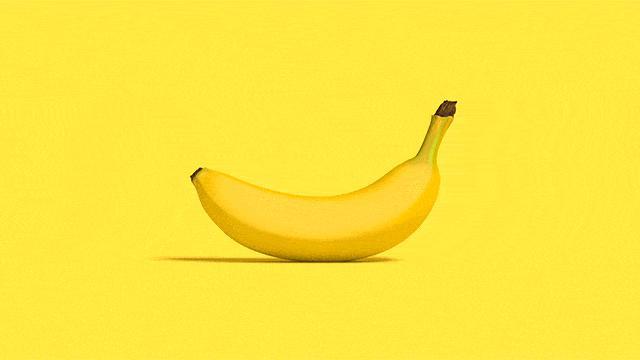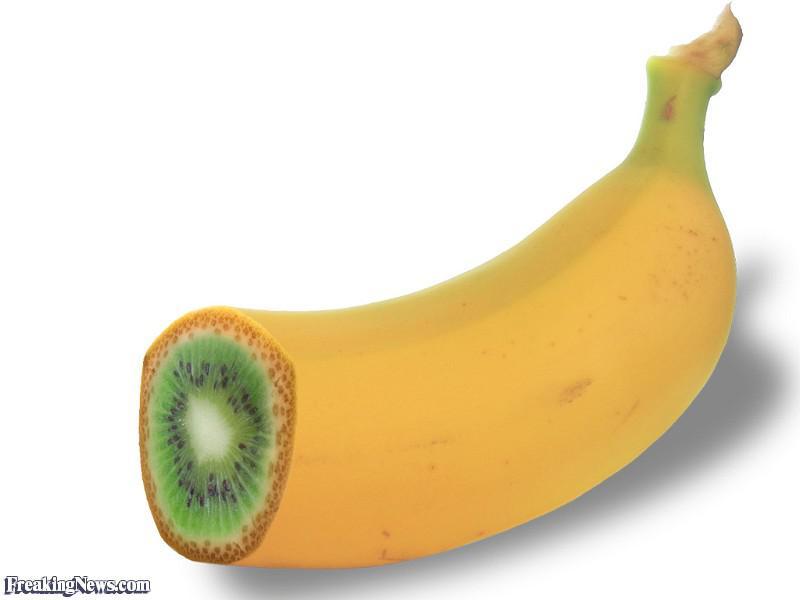The first image is the image on the left, the second image is the image on the right. Analyze the images presented: Is the assertion "One of the images features a vegetable turning in to a banana." valid? Answer yes or no. No. 